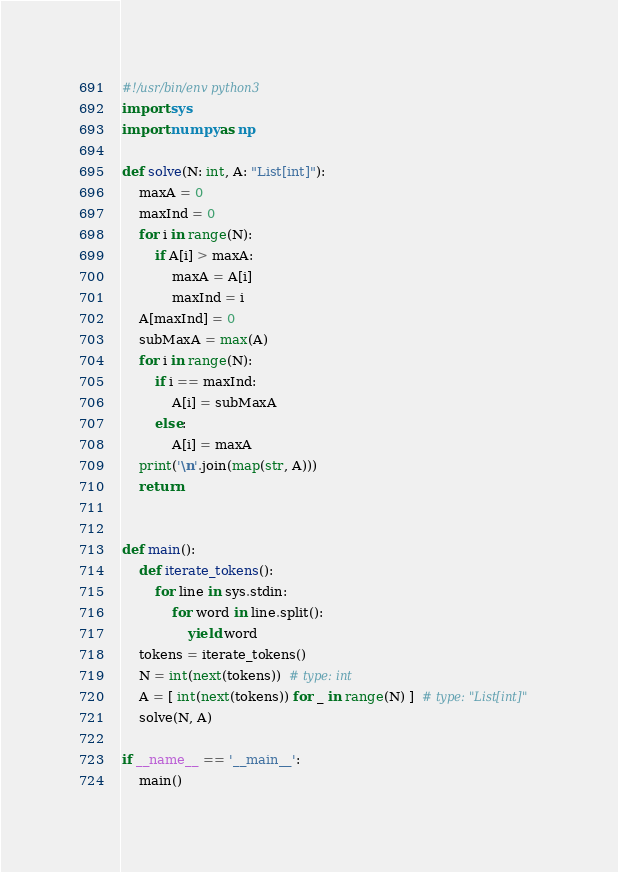Convert code to text. <code><loc_0><loc_0><loc_500><loc_500><_Python_>#!/usr/bin/env python3
import sys
import numpy as np

def solve(N: int, A: "List[int]"):
    maxA = 0
    maxInd = 0
    for i in range(N):
        if A[i] > maxA:
            maxA = A[i]
            maxInd = i
    A[maxInd] = 0
    subMaxA = max(A)
    for i in range(N):
        if i == maxInd:
            A[i] = subMaxA
        else:
            A[i] = maxA
    print('\n'.join(map(str, A)))
    return


def main():
    def iterate_tokens():
        for line in sys.stdin:
            for word in line.split():
                yield word
    tokens = iterate_tokens()
    N = int(next(tokens))  # type: int
    A = [ int(next(tokens)) for _ in range(N) ]  # type: "List[int]"
    solve(N, A)

if __name__ == '__main__':
    main()
</code> 